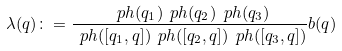<formula> <loc_0><loc_0><loc_500><loc_500>\lambda ( q ) \colon = \frac { \ p h ( q _ { 1 } ) \ p h ( q _ { 2 } ) \ p h ( q _ { 3 } ) } { \ p h ( [ q _ { 1 } , q ] ) \ p h ( [ q _ { 2 } , q ] ) \ p h ( [ q _ { 3 } , q ] ) } b ( q )</formula> 